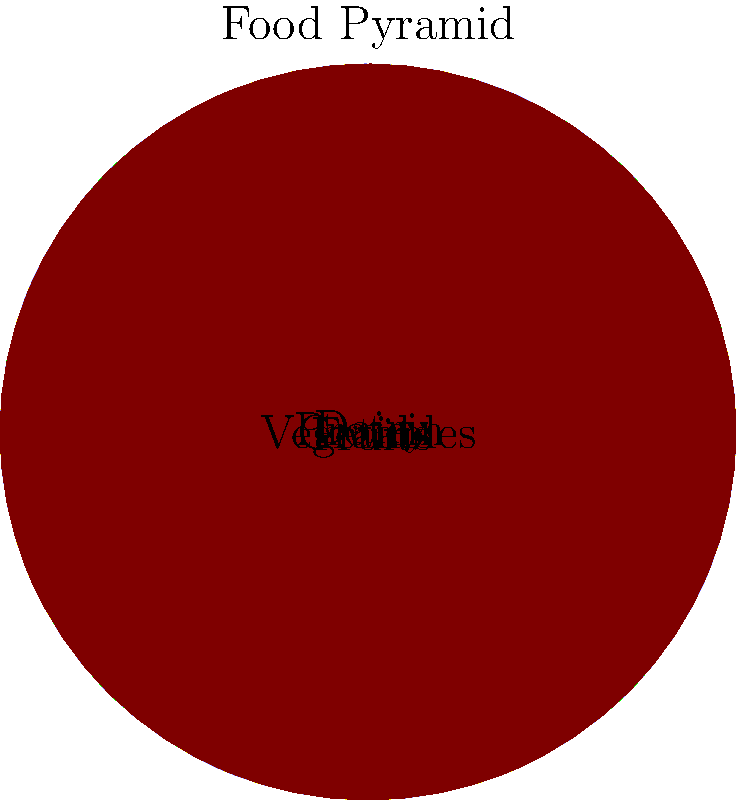According to the food pyramid shown, which food group has the highest recommended daily servings? To determine which food group has the highest recommended daily servings, we need to analyze the food pyramid diagram:

1. The food pyramid is divided into five sections, each representing a different food group.
2. The size of each section corresponds to the recommended daily servings for that group.
3. The food groups shown are: Grains, Vegetables, Fruits, Dairy, and Protein.
4. By comparing the sizes of the sections:
   - Grains occupy the largest portion of the circle
   - Vegetables and Protein have equal, smaller portions
   - Fruits and Dairy have the smallest, equal portions
5. The largest section corresponds to the food group with the highest recommended daily servings.

Therefore, the food group with the highest recommended daily servings is Grains.
Answer: Grains 